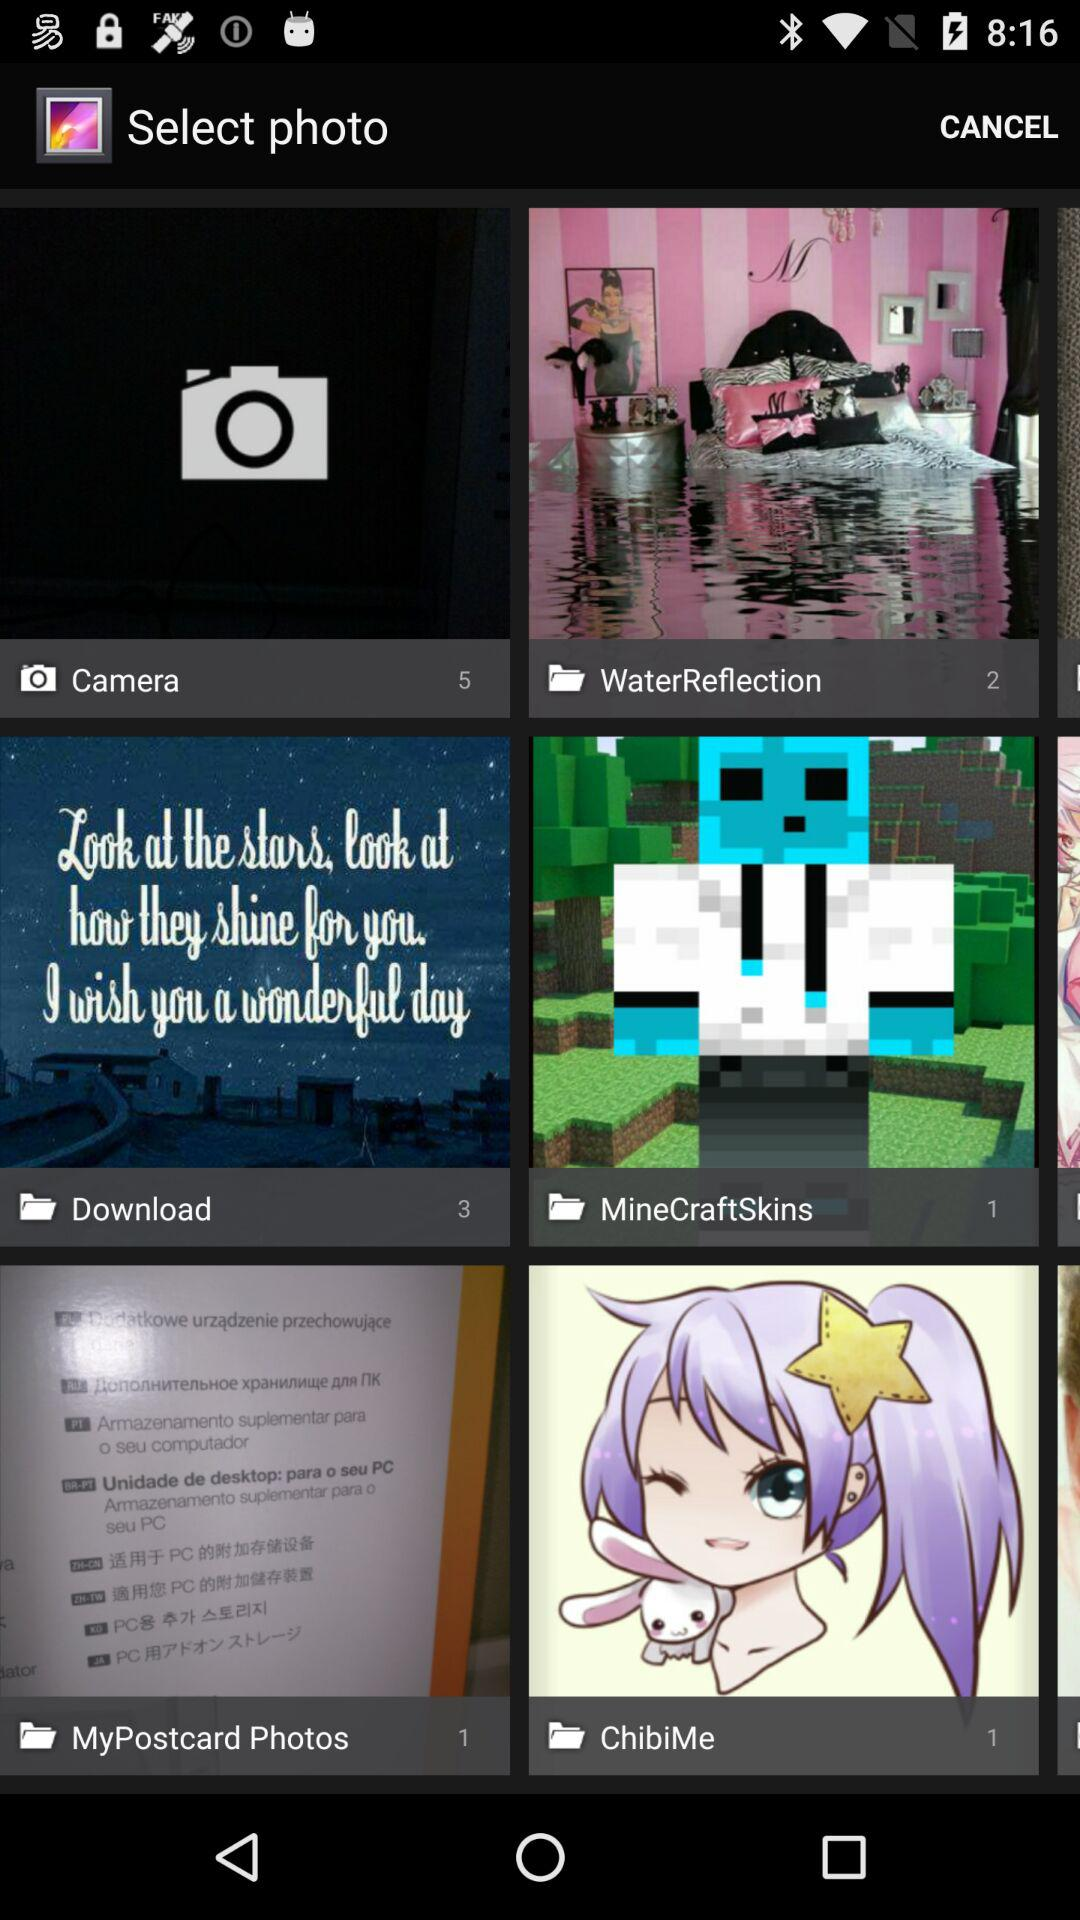What total number of images are there in the "WaterReflection" folder? The total number of images is 2. 